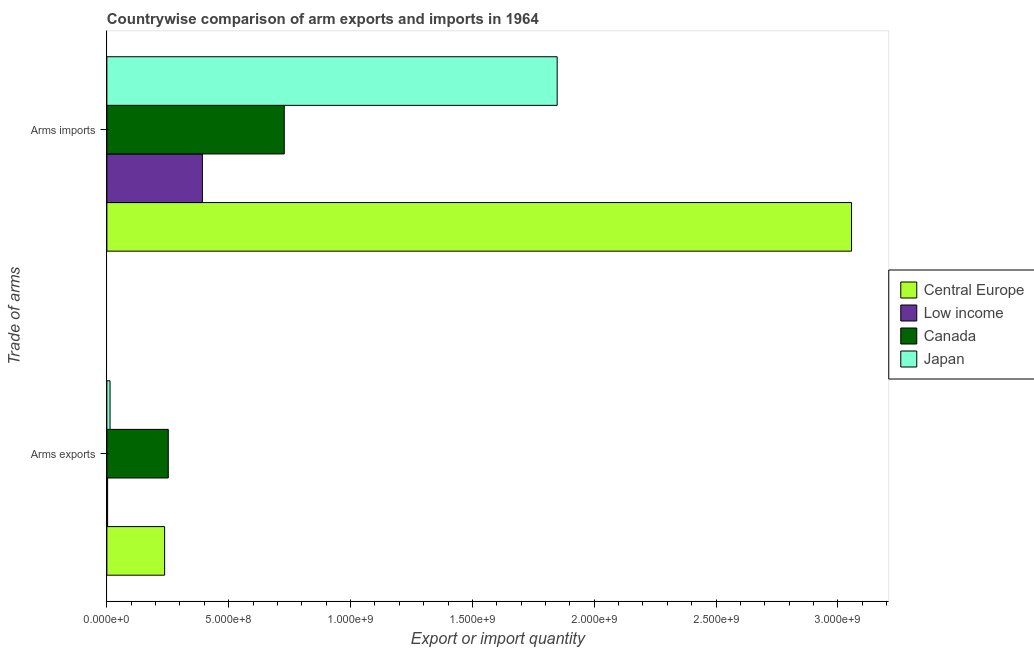Are the number of bars on each tick of the Y-axis equal?
Your answer should be very brief. Yes. How many bars are there on the 2nd tick from the bottom?
Provide a succinct answer. 4. What is the label of the 2nd group of bars from the top?
Provide a succinct answer. Arms exports. What is the arms imports in Central Europe?
Your answer should be very brief. 3.06e+09. Across all countries, what is the maximum arms imports?
Provide a short and direct response. 3.06e+09. Across all countries, what is the minimum arms imports?
Your answer should be compact. 3.92e+08. In which country was the arms imports maximum?
Provide a short and direct response. Central Europe. In which country was the arms imports minimum?
Offer a very short reply. Low income. What is the total arms imports in the graph?
Offer a terse response. 6.02e+09. What is the difference between the arms imports in Low income and that in Japan?
Offer a very short reply. -1.46e+09. What is the difference between the arms exports in Low income and the arms imports in Japan?
Your answer should be very brief. -1.84e+09. What is the average arms exports per country?
Your answer should be very brief. 1.26e+08. What is the difference between the arms imports and arms exports in Canada?
Offer a very short reply. 4.76e+08. What is the ratio of the arms imports in Central Europe to that in Low income?
Provide a succinct answer. 7.8. Is the arms imports in Japan less than that in Central Europe?
Ensure brevity in your answer.  Yes. What does the 3rd bar from the top in Arms exports represents?
Make the answer very short. Low income. What does the 4th bar from the bottom in Arms exports represents?
Your answer should be very brief. Japan. What is the difference between two consecutive major ticks on the X-axis?
Your answer should be very brief. 5.00e+08. Does the graph contain any zero values?
Provide a short and direct response. No. Where does the legend appear in the graph?
Your answer should be compact. Center right. What is the title of the graph?
Offer a very short reply. Countrywise comparison of arm exports and imports in 1964. What is the label or title of the X-axis?
Your response must be concise. Export or import quantity. What is the label or title of the Y-axis?
Keep it short and to the point. Trade of arms. What is the Export or import quantity in Central Europe in Arms exports?
Your response must be concise. 2.37e+08. What is the Export or import quantity in Low income in Arms exports?
Offer a terse response. 3.00e+06. What is the Export or import quantity in Canada in Arms exports?
Ensure brevity in your answer.  2.52e+08. What is the Export or import quantity in Japan in Arms exports?
Offer a terse response. 1.30e+07. What is the Export or import quantity of Central Europe in Arms imports?
Your answer should be compact. 3.06e+09. What is the Export or import quantity in Low income in Arms imports?
Your response must be concise. 3.92e+08. What is the Export or import quantity of Canada in Arms imports?
Ensure brevity in your answer.  7.28e+08. What is the Export or import quantity of Japan in Arms imports?
Offer a terse response. 1.85e+09. Across all Trade of arms, what is the maximum Export or import quantity in Central Europe?
Offer a terse response. 3.06e+09. Across all Trade of arms, what is the maximum Export or import quantity in Low income?
Provide a succinct answer. 3.92e+08. Across all Trade of arms, what is the maximum Export or import quantity in Canada?
Offer a terse response. 7.28e+08. Across all Trade of arms, what is the maximum Export or import quantity of Japan?
Ensure brevity in your answer.  1.85e+09. Across all Trade of arms, what is the minimum Export or import quantity of Central Europe?
Ensure brevity in your answer.  2.37e+08. Across all Trade of arms, what is the minimum Export or import quantity in Low income?
Provide a short and direct response. 3.00e+06. Across all Trade of arms, what is the minimum Export or import quantity in Canada?
Make the answer very short. 2.52e+08. Across all Trade of arms, what is the minimum Export or import quantity in Japan?
Give a very brief answer. 1.30e+07. What is the total Export or import quantity of Central Europe in the graph?
Ensure brevity in your answer.  3.29e+09. What is the total Export or import quantity of Low income in the graph?
Give a very brief answer. 3.95e+08. What is the total Export or import quantity in Canada in the graph?
Your answer should be very brief. 9.80e+08. What is the total Export or import quantity of Japan in the graph?
Your answer should be compact. 1.86e+09. What is the difference between the Export or import quantity in Central Europe in Arms exports and that in Arms imports?
Make the answer very short. -2.82e+09. What is the difference between the Export or import quantity of Low income in Arms exports and that in Arms imports?
Provide a short and direct response. -3.89e+08. What is the difference between the Export or import quantity in Canada in Arms exports and that in Arms imports?
Offer a terse response. -4.76e+08. What is the difference between the Export or import quantity in Japan in Arms exports and that in Arms imports?
Your answer should be compact. -1.84e+09. What is the difference between the Export or import quantity of Central Europe in Arms exports and the Export or import quantity of Low income in Arms imports?
Your answer should be compact. -1.55e+08. What is the difference between the Export or import quantity of Central Europe in Arms exports and the Export or import quantity of Canada in Arms imports?
Your answer should be very brief. -4.91e+08. What is the difference between the Export or import quantity of Central Europe in Arms exports and the Export or import quantity of Japan in Arms imports?
Your answer should be very brief. -1.61e+09. What is the difference between the Export or import quantity in Low income in Arms exports and the Export or import quantity in Canada in Arms imports?
Provide a short and direct response. -7.25e+08. What is the difference between the Export or import quantity in Low income in Arms exports and the Export or import quantity in Japan in Arms imports?
Give a very brief answer. -1.84e+09. What is the difference between the Export or import quantity in Canada in Arms exports and the Export or import quantity in Japan in Arms imports?
Make the answer very short. -1.60e+09. What is the average Export or import quantity in Central Europe per Trade of arms?
Provide a short and direct response. 1.65e+09. What is the average Export or import quantity of Low income per Trade of arms?
Provide a short and direct response. 1.98e+08. What is the average Export or import quantity of Canada per Trade of arms?
Ensure brevity in your answer.  4.90e+08. What is the average Export or import quantity in Japan per Trade of arms?
Offer a very short reply. 9.30e+08. What is the difference between the Export or import quantity in Central Europe and Export or import quantity in Low income in Arms exports?
Keep it short and to the point. 2.34e+08. What is the difference between the Export or import quantity of Central Europe and Export or import quantity of Canada in Arms exports?
Offer a very short reply. -1.50e+07. What is the difference between the Export or import quantity in Central Europe and Export or import quantity in Japan in Arms exports?
Offer a terse response. 2.24e+08. What is the difference between the Export or import quantity in Low income and Export or import quantity in Canada in Arms exports?
Keep it short and to the point. -2.49e+08. What is the difference between the Export or import quantity in Low income and Export or import quantity in Japan in Arms exports?
Offer a very short reply. -1.00e+07. What is the difference between the Export or import quantity in Canada and Export or import quantity in Japan in Arms exports?
Your answer should be compact. 2.39e+08. What is the difference between the Export or import quantity in Central Europe and Export or import quantity in Low income in Arms imports?
Your answer should be very brief. 2.66e+09. What is the difference between the Export or import quantity of Central Europe and Export or import quantity of Canada in Arms imports?
Your answer should be compact. 2.33e+09. What is the difference between the Export or import quantity of Central Europe and Export or import quantity of Japan in Arms imports?
Your answer should be compact. 1.21e+09. What is the difference between the Export or import quantity in Low income and Export or import quantity in Canada in Arms imports?
Make the answer very short. -3.36e+08. What is the difference between the Export or import quantity of Low income and Export or import quantity of Japan in Arms imports?
Offer a terse response. -1.46e+09. What is the difference between the Export or import quantity in Canada and Export or import quantity in Japan in Arms imports?
Your answer should be compact. -1.12e+09. What is the ratio of the Export or import quantity in Central Europe in Arms exports to that in Arms imports?
Ensure brevity in your answer.  0.08. What is the ratio of the Export or import quantity in Low income in Arms exports to that in Arms imports?
Provide a short and direct response. 0.01. What is the ratio of the Export or import quantity of Canada in Arms exports to that in Arms imports?
Your response must be concise. 0.35. What is the ratio of the Export or import quantity in Japan in Arms exports to that in Arms imports?
Offer a terse response. 0.01. What is the difference between the highest and the second highest Export or import quantity in Central Europe?
Your answer should be very brief. 2.82e+09. What is the difference between the highest and the second highest Export or import quantity in Low income?
Offer a very short reply. 3.89e+08. What is the difference between the highest and the second highest Export or import quantity of Canada?
Offer a very short reply. 4.76e+08. What is the difference between the highest and the second highest Export or import quantity in Japan?
Your answer should be very brief. 1.84e+09. What is the difference between the highest and the lowest Export or import quantity in Central Europe?
Ensure brevity in your answer.  2.82e+09. What is the difference between the highest and the lowest Export or import quantity in Low income?
Your answer should be compact. 3.89e+08. What is the difference between the highest and the lowest Export or import quantity of Canada?
Your answer should be compact. 4.76e+08. What is the difference between the highest and the lowest Export or import quantity of Japan?
Your answer should be very brief. 1.84e+09. 